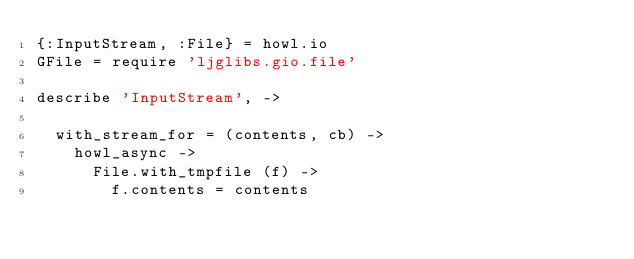<code> <loc_0><loc_0><loc_500><loc_500><_MoonScript_>{:InputStream, :File} = howl.io
GFile = require 'ljglibs.gio.file'

describe 'InputStream', ->

  with_stream_for = (contents, cb) ->
    howl_async ->
      File.with_tmpfile (f) ->
        f.contents = contents</code> 